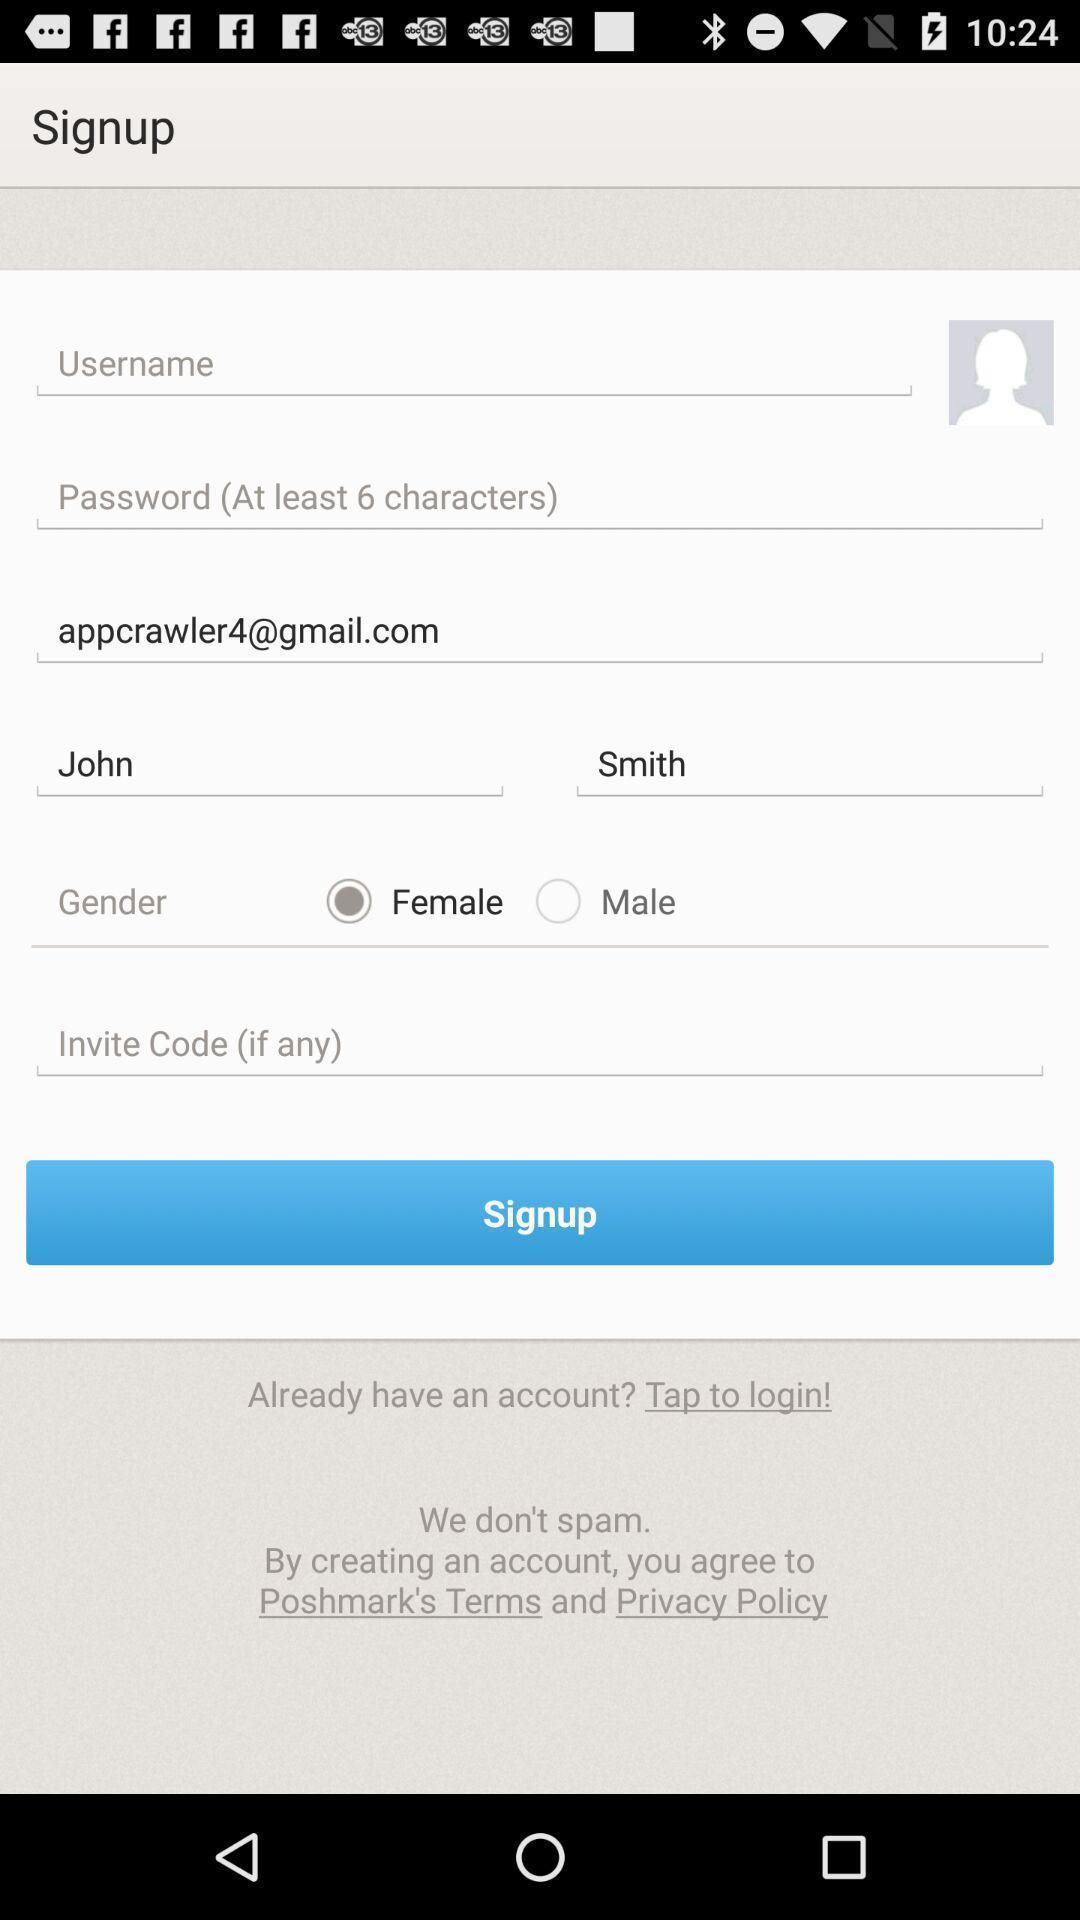What details can you identify in this image? Sign up page of the app. 